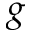<formula> <loc_0><loc_0><loc_500><loc_500>g</formula> 